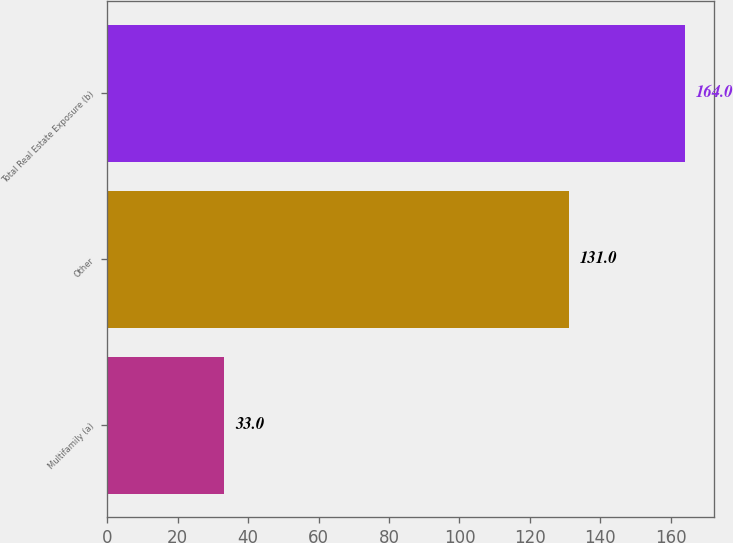<chart> <loc_0><loc_0><loc_500><loc_500><bar_chart><fcel>Multifamily (a)<fcel>Other<fcel>Total Real Estate Exposure (b)<nl><fcel>33<fcel>131<fcel>164<nl></chart> 